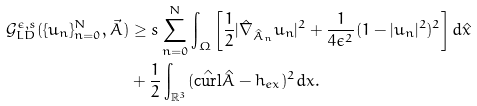<formula> <loc_0><loc_0><loc_500><loc_500>\mathcal { G } _ { L D } ^ { \epsilon , s } ( \{ u _ { n } \} _ { n = 0 } ^ { N } , \vec { A } ) & \geq s \sum ^ { N } _ { n = 0 } \int _ { \Omega } \left [ \frac { 1 } { 2 } | \hat { \nabla } _ { \hat { A } _ { n } } u _ { n } | ^ { 2 } + \frac { 1 } { 4 \epsilon ^ { 2 } } ( 1 - | u _ { n } | ^ { 2 } ) ^ { 2 } \right ] d \hat { x } \\ & + \frac { 1 } { 2 } \int _ { \mathbb { R } ^ { 3 } } ( \hat { \text {curl} } \hat { A } - h _ { e x } ) ^ { 2 } d x .</formula> 